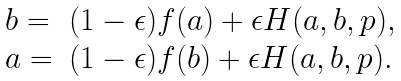Convert formula to latex. <formula><loc_0><loc_0><loc_500><loc_500>\begin{array} { l l } b = & ( 1 - \epsilon ) f ( a ) + \epsilon H ( a , b , p ) , \\ a = & ( 1 - \epsilon ) f ( b ) + \epsilon H ( a , b , p ) . \end{array}</formula> 